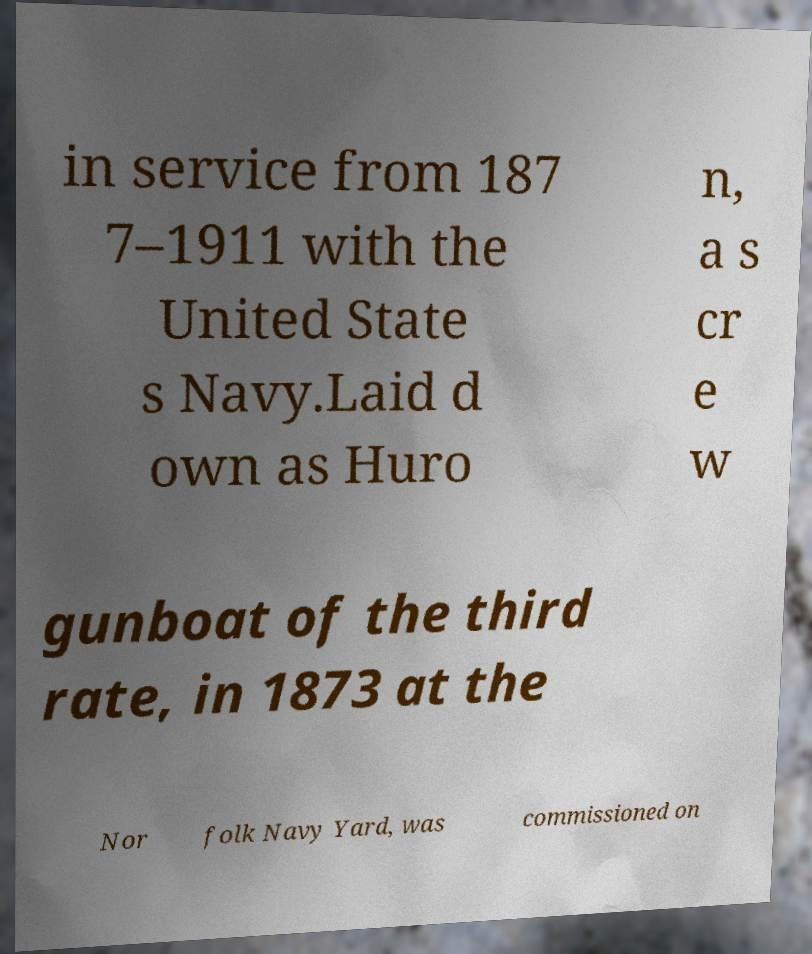What messages or text are displayed in this image? I need them in a readable, typed format. in service from 187 7–1911 with the United State s Navy.Laid d own as Huro n, a s cr e w gunboat of the third rate, in 1873 at the Nor folk Navy Yard, was commissioned on 